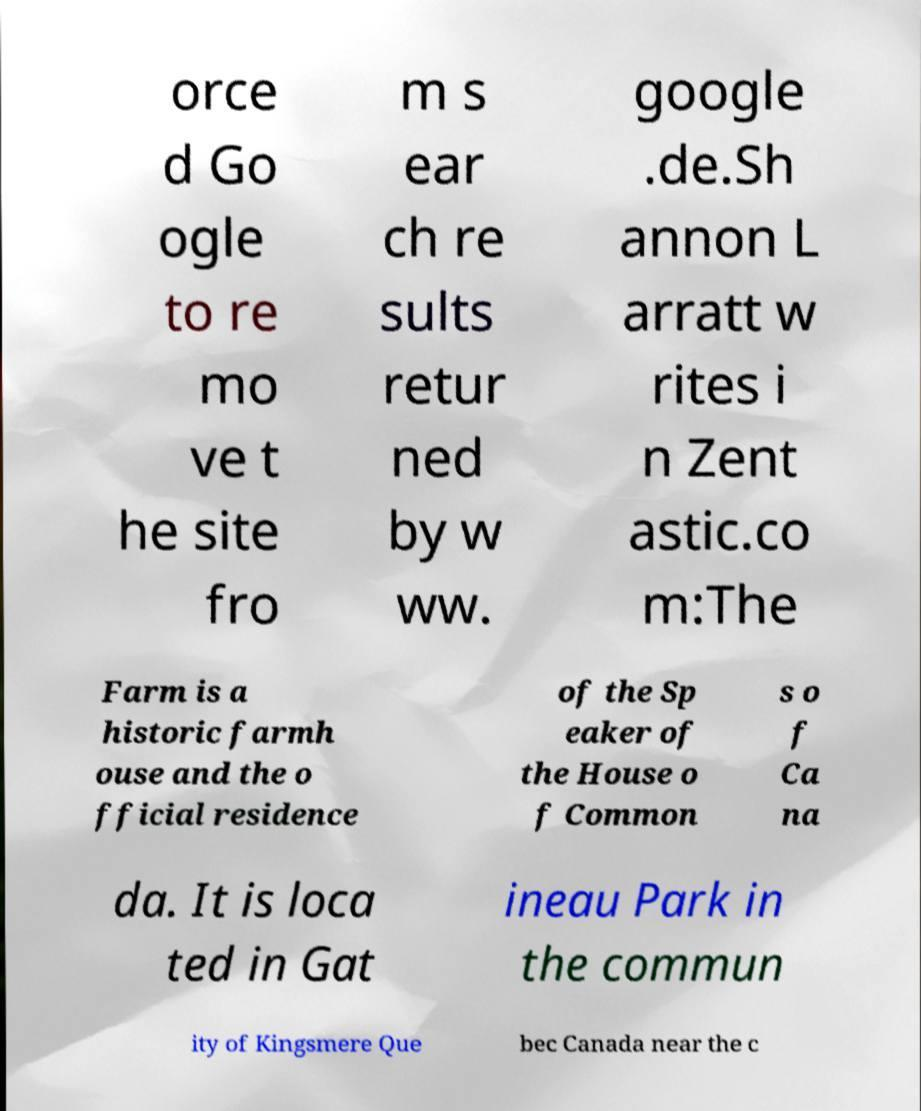What messages or text are displayed in this image? I need them in a readable, typed format. orce d Go ogle to re mo ve t he site fro m s ear ch re sults retur ned by w ww. google .de.Sh annon L arratt w rites i n Zent astic.co m:The Farm is a historic farmh ouse and the o fficial residence of the Sp eaker of the House o f Common s o f Ca na da. It is loca ted in Gat ineau Park in the commun ity of Kingsmere Que bec Canada near the c 